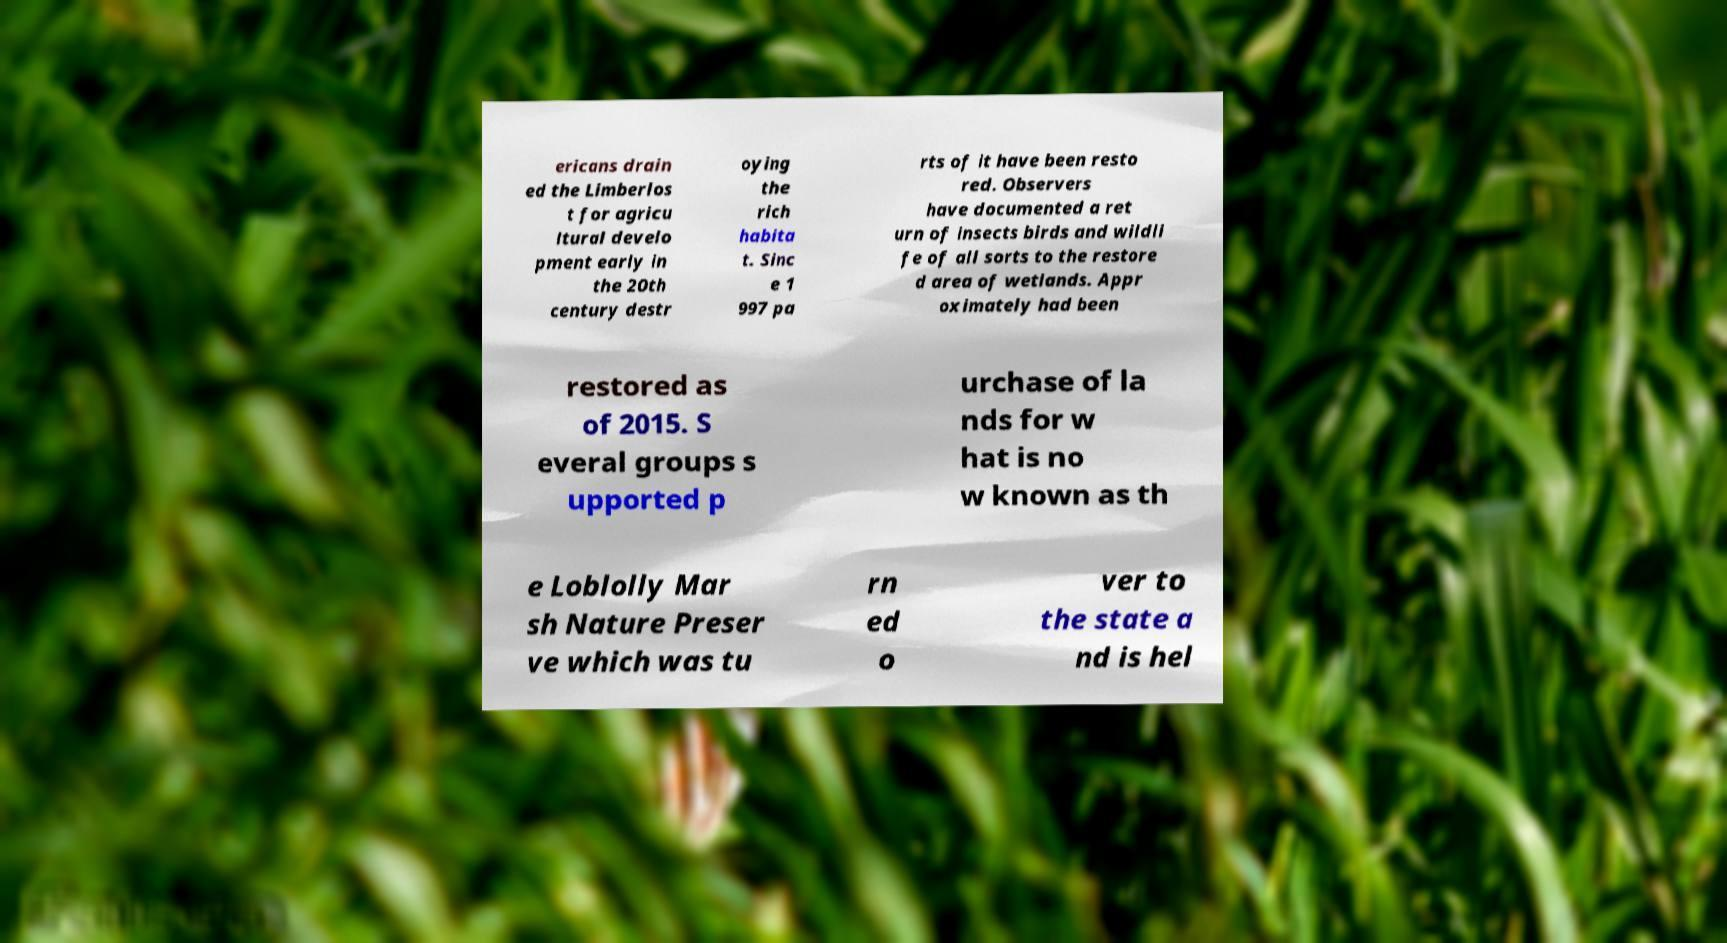For documentation purposes, I need the text within this image transcribed. Could you provide that? ericans drain ed the Limberlos t for agricu ltural develo pment early in the 20th century destr oying the rich habita t. Sinc e 1 997 pa rts of it have been resto red. Observers have documented a ret urn of insects birds and wildli fe of all sorts to the restore d area of wetlands. Appr oximately had been restored as of 2015. S everal groups s upported p urchase of la nds for w hat is no w known as th e Loblolly Mar sh Nature Preser ve which was tu rn ed o ver to the state a nd is hel 